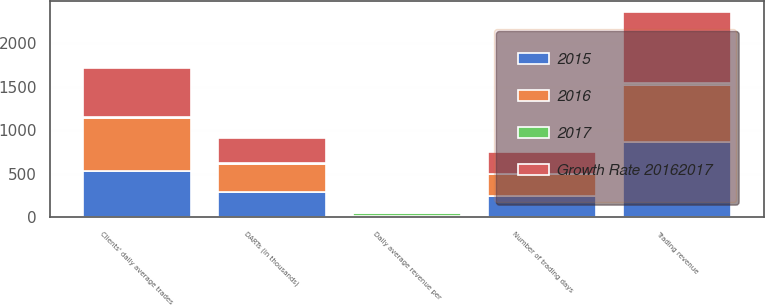Convert chart to OTSL. <chart><loc_0><loc_0><loc_500><loc_500><stacked_bar_chart><ecel><fcel>DARTs (in thousands)<fcel>Clients' daily average trades<fcel>Number of trading days<fcel>Daily average revenue per<fcel>Trading revenue<nl><fcel>2017<fcel>10<fcel>8<fcel>1<fcel>27<fcel>21<nl><fcel>2016<fcel>321.3<fcel>608.8<fcel>250<fcel>8.2<fcel>654<nl><fcel>Growth Rate 20162017<fcel>291.6<fcel>561.8<fcel>251.5<fcel>11.23<fcel>825<nl><fcel>2015<fcel>292<fcel>536.9<fcel>251<fcel>11.83<fcel>866<nl></chart> 